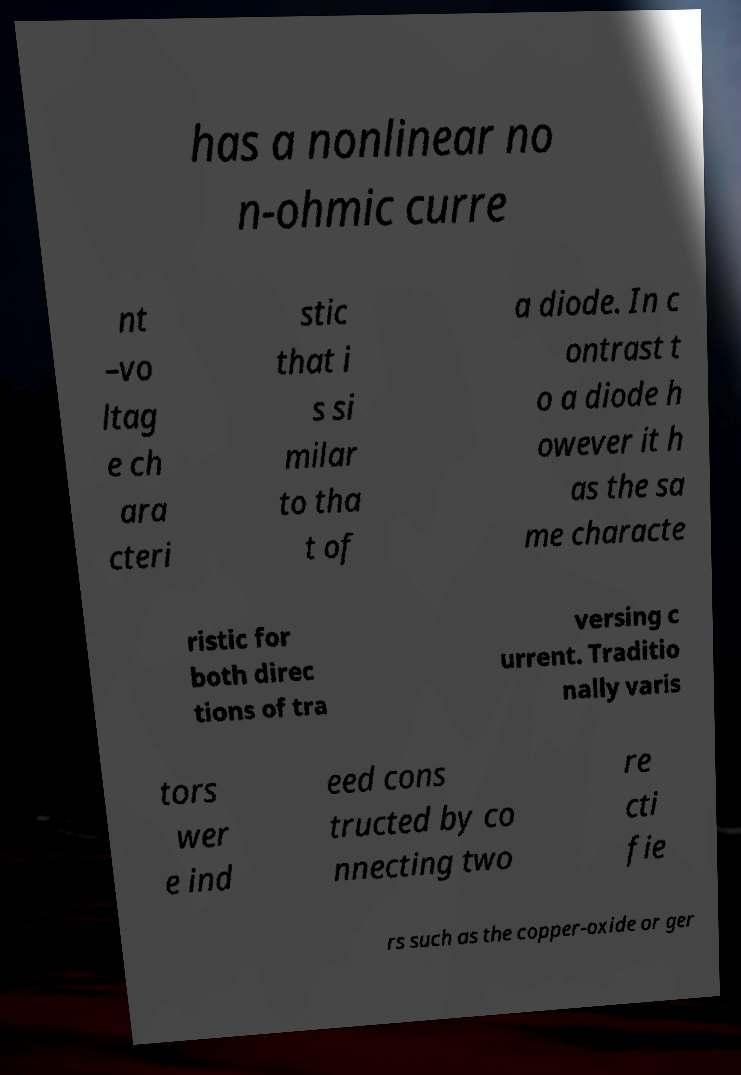Can you read and provide the text displayed in the image?This photo seems to have some interesting text. Can you extract and type it out for me? has a nonlinear no n-ohmic curre nt –vo ltag e ch ara cteri stic that i s si milar to tha t of a diode. In c ontrast t o a diode h owever it h as the sa me characte ristic for both direc tions of tra versing c urrent. Traditio nally varis tors wer e ind eed cons tructed by co nnecting two re cti fie rs such as the copper-oxide or ger 